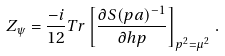Convert formula to latex. <formula><loc_0><loc_0><loc_500><loc_500>Z _ { \psi } = \frac { - i } { 1 2 } { T r } \left [ \frac { \partial S ( p a ) ^ { - 1 } } { \partial \sl h { p } } \right ] _ { p ^ { 2 } = \mu ^ { 2 } } \, .</formula> 